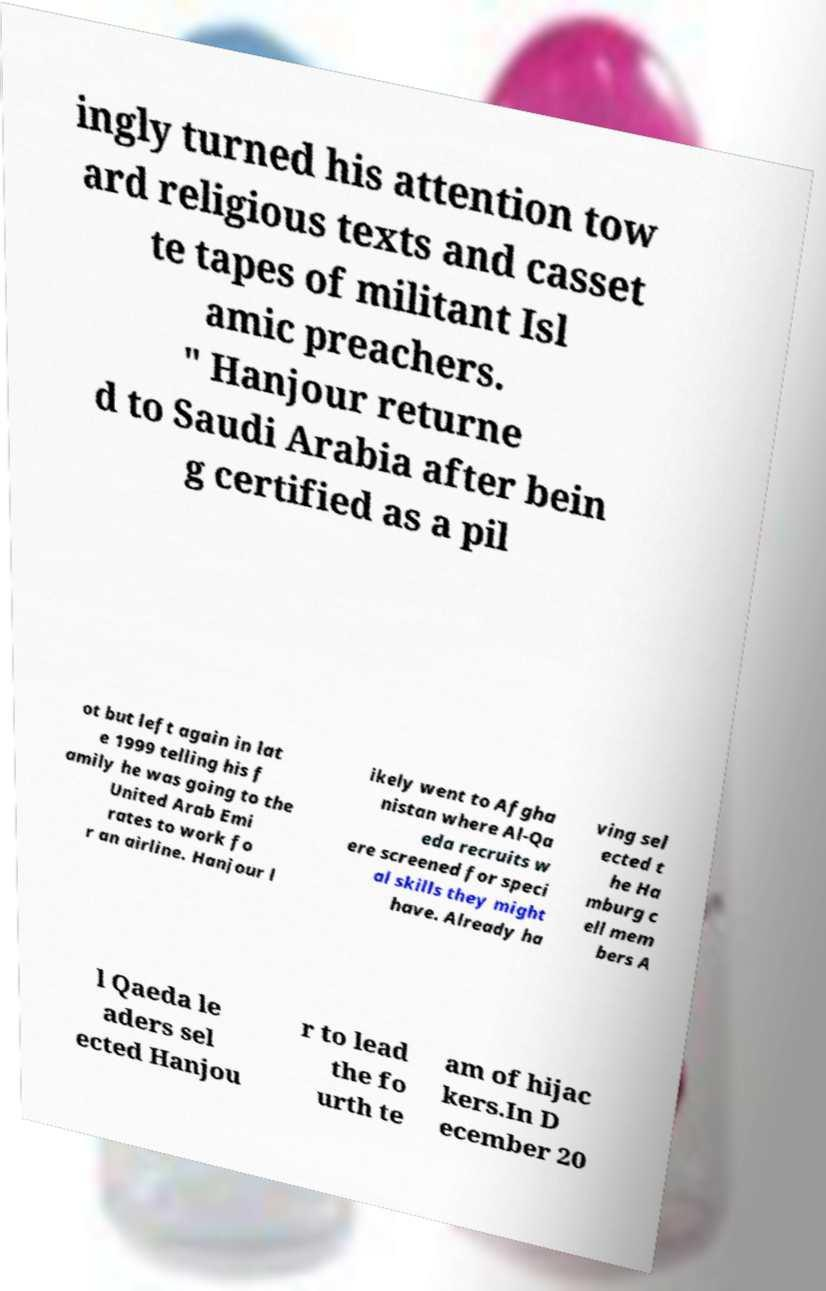I need the written content from this picture converted into text. Can you do that? ingly turned his attention tow ard religious texts and casset te tapes of militant Isl amic preachers. " Hanjour returne d to Saudi Arabia after bein g certified as a pil ot but left again in lat e 1999 telling his f amily he was going to the United Arab Emi rates to work fo r an airline. Hanjour l ikely went to Afgha nistan where Al-Qa eda recruits w ere screened for speci al skills they might have. Already ha ving sel ected t he Ha mburg c ell mem bers A l Qaeda le aders sel ected Hanjou r to lead the fo urth te am of hijac kers.In D ecember 20 